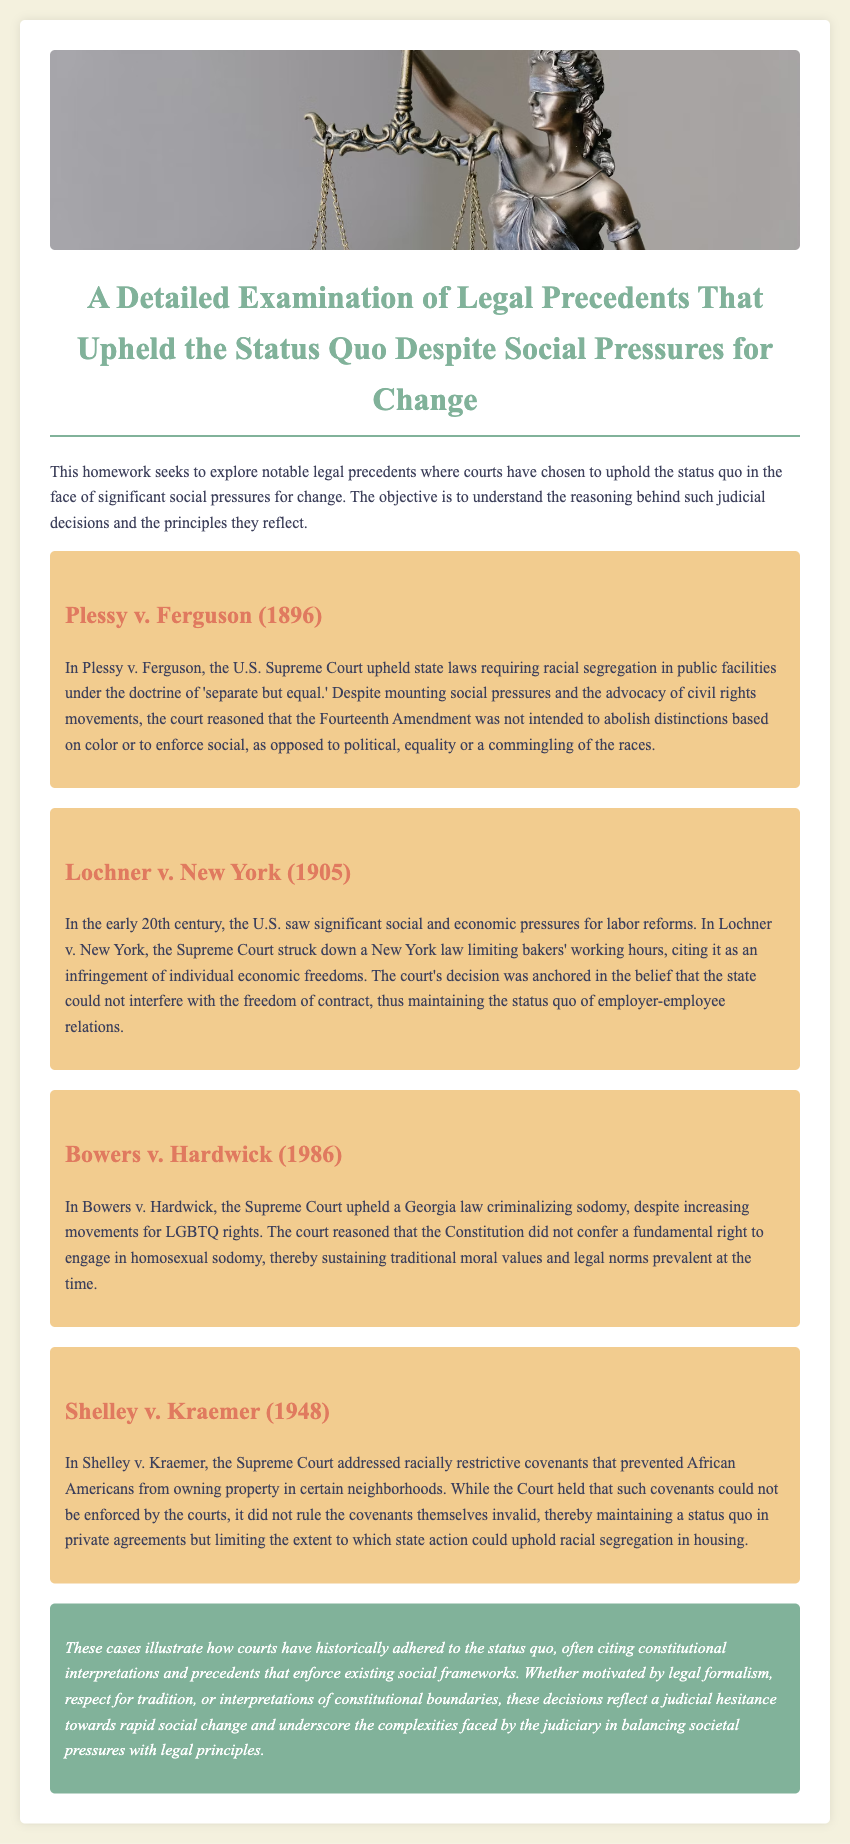What is the title of the document? The title is provided in a prominent position at the top of the document and describes the main topic of analysis.
Answer: A Detailed Examination of Legal Precedents That Upheld the Status Quo Despite Social Pressures for Change Who wrote the dissenting opinion in Plessy v. Ferguson? The document does not specify who wrote the dissenting opinion, nor does it provide details about dissenting opinions in the cases discussed.
Answer: Not mentioned What year was Lochner v. New York decided? The year of the decision is stated in the heading of the section discussing the case.
Answer: 1905 What was the Fourteenth Amendment’s intended purpose according to the court in Plessy v. Ferguson? The document cites the court's reasoning regarding the intended purpose of the Fourteenth Amendment directly in relation to racial distinctions.
Answer: Not intended to abolish distinctions based on color Which case upheld a law criminalizing sodomy? The answer can be found in the section discussing legal precedents related to LGBTQ rights within the document.
Answer: Bowers v. Hardwick What principle did the Supreme Court reinforce in Lochner v. New York? The section on Lochner v. New York discusses the principle related to individual rights that the court prioritized in its ruling.
Answer: Freedom of contract In what year was Shelley v. Kraemer decided? The year of the decision is mentioned along with the case's title in the document.
Answer: 1948 What kind of covenants were discussed in Shelley v. Kraemer? The document specifies the type of covenants addressed in the case as part of the decision-making process.
Answer: Racially restrictive covenants 